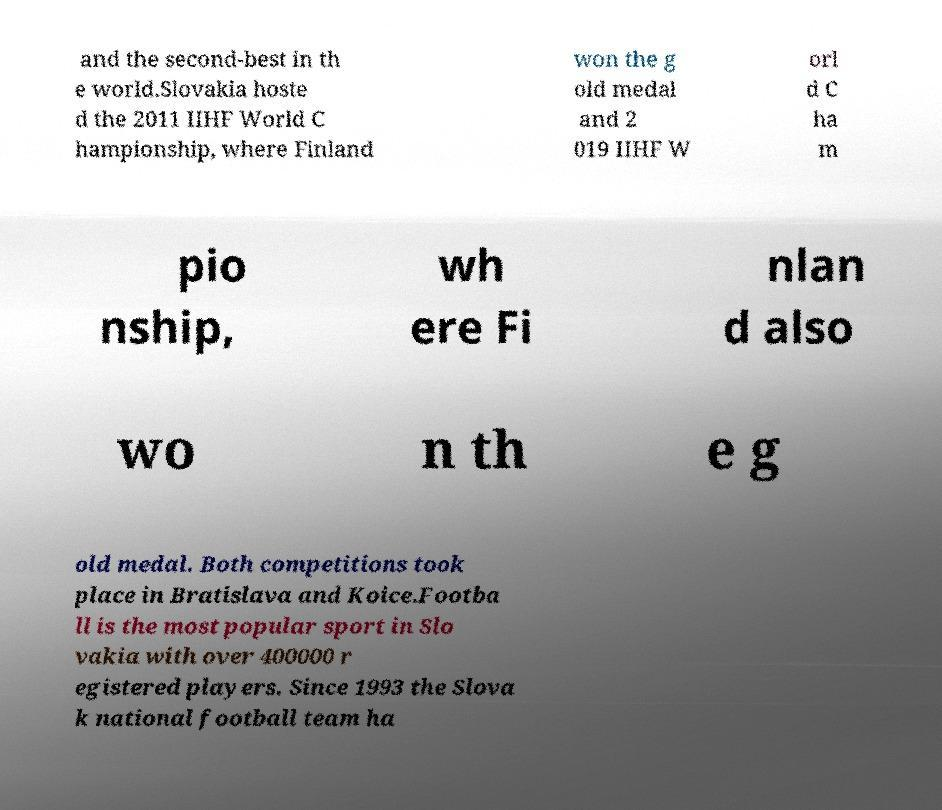Can you read and provide the text displayed in the image?This photo seems to have some interesting text. Can you extract and type it out for me? and the second-best in th e world.Slovakia hoste d the 2011 IIHF World C hampionship, where Finland won the g old medal and 2 019 IIHF W orl d C ha m pio nship, wh ere Fi nlan d also wo n th e g old medal. Both competitions took place in Bratislava and Koice.Footba ll is the most popular sport in Slo vakia with over 400000 r egistered players. Since 1993 the Slova k national football team ha 